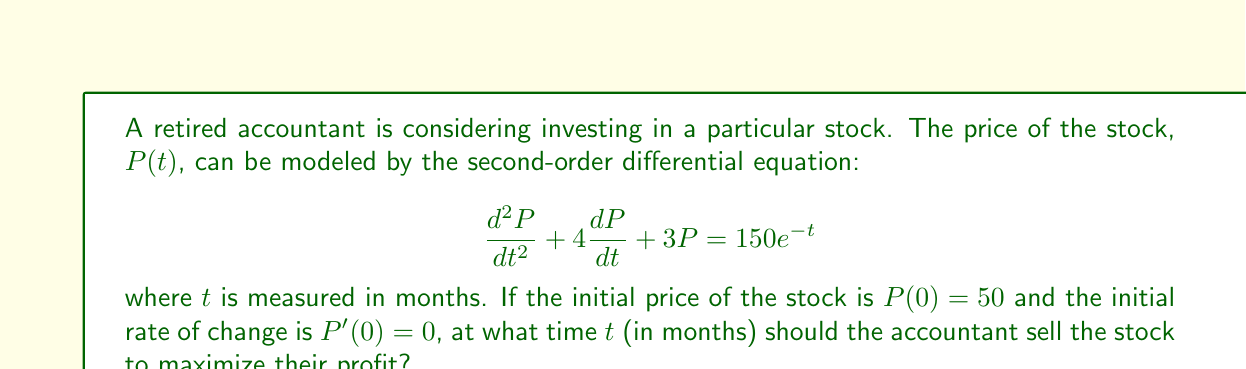Can you solve this math problem? To solve this problem, we need to follow these steps:

1) First, we need to find the general solution to the differential equation. The homogeneous solution is:

   $$P_h(t) = c_1e^{-t} + c_2e^{-3t}$$

2) The particular solution has the form:

   $$P_p(t) = Ate^{-t}$$

   Substituting this into the original equation:

   $$(-A + 4A + 3At)e^{-t} = 150e^{-t}$$

   This gives us $A = 50$.

3) The complete solution is:

   $$P(t) = c_1e^{-t} + c_2e^{-3t} + 50te^{-t}$$

4) Using the initial conditions:

   $P(0) = 50$: $c_1 + c_2 = 50$
   $P'(0) = 0$: $-c_1 - 3c_2 + 50 = 0$

   Solving these equations gives: $c_1 = 75$ and $c_2 = -25$

5) Therefore, the price function is:

   $$P(t) = 75e^{-t} - 25e^{-3t} + 50te^{-t}$$

6) To find the maximum, we differentiate and set to zero:

   $$\frac{dP}{dt} = -75e^{-t} + 75e^{-3t} + 50e^{-t} - 50te^{-t} = 0$$

7) Simplifying:

   $$-25e^{-t} + 75e^{-3t} - 50te^{-t} = 0$$

   $$-25 + 75e^{-2t} - 50t = 0$$

8) This equation can be solved numerically. Using a graphing calculator or numerical methods, we find that $t \approx 1.61$ months.

9) To confirm this is a maximum, we can check the second derivative is negative at this point.
Answer: The accountant should sell the stock after approximately 1.61 months to maximize their profit. 